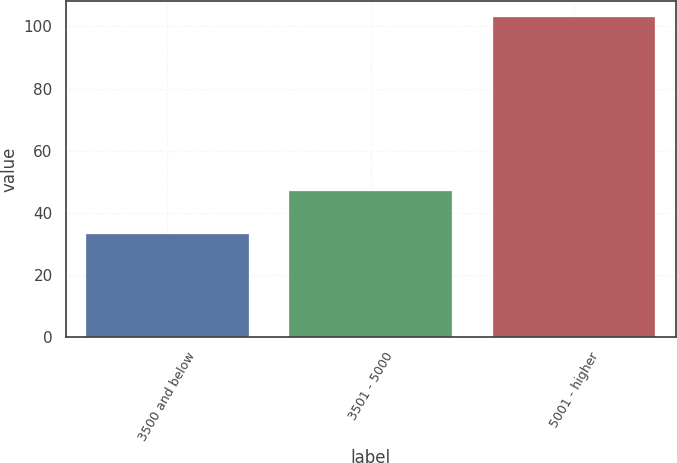Convert chart. <chart><loc_0><loc_0><loc_500><loc_500><bar_chart><fcel>3500 and below<fcel>3501 - 5000<fcel>5001 - higher<nl><fcel>33.11<fcel>46.97<fcel>102.95<nl></chart> 